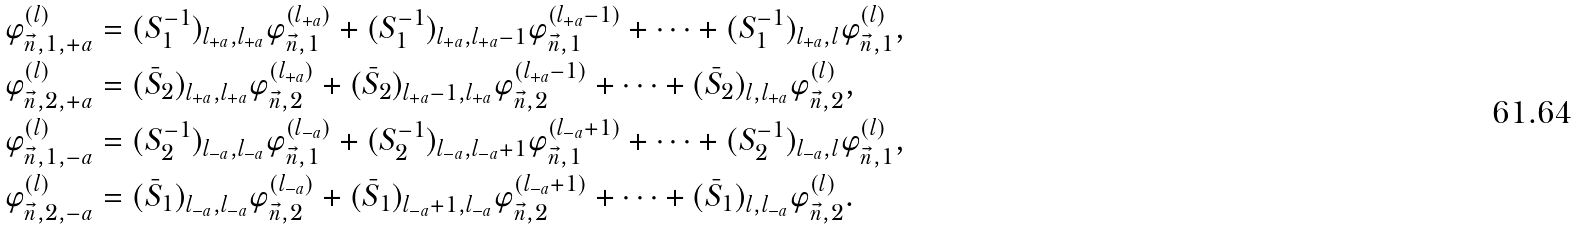<formula> <loc_0><loc_0><loc_500><loc_500>\varphi ^ { ( l ) } _ { \vec { n } , 1 , + a } & = ( S _ { 1 } ^ { - 1 } ) _ { l _ { + a } , l _ { + a } } \varphi ^ { ( l _ { + a } ) } _ { \vec { n } , 1 } + ( S _ { 1 } ^ { - 1 } ) _ { l _ { + a } , l _ { + a } - 1 } \varphi ^ { ( l _ { + a } - 1 ) } _ { \vec { n } , 1 } + \cdots + ( S _ { 1 } ^ { - 1 } ) _ { l _ { + a } , l } \varphi ^ { ( l ) } _ { \vec { n } , 1 } , \\ \varphi ^ { ( l ) } _ { \vec { n } , 2 , + a } & = ( \bar { S } _ { 2 } ) _ { l _ { + a } , l _ { + a } } \varphi ^ { ( l _ { + a } ) } _ { \vec { n } , 2 } + ( \bar { S } _ { 2 } ) _ { l _ { + a } - 1 , l _ { + a } } \varphi ^ { ( l _ { + a } - 1 ) } _ { \vec { n } , 2 } + \cdots + ( \bar { S } _ { 2 } ) _ { l , l _ { + a } } \varphi ^ { ( l ) } _ { \vec { n } , 2 } , \\ \varphi ^ { ( l ) } _ { \vec { n } , 1 , - a } & = ( S _ { 2 } ^ { - 1 } ) _ { l _ { - a } , l _ { - a } } \varphi ^ { ( l _ { - a } ) } _ { \vec { n } , 1 } + ( S _ { 2 } ^ { - 1 } ) _ { l _ { - a } , l _ { - a } + 1 } \varphi ^ { ( l _ { - a } + 1 ) } _ { \vec { n } , 1 } + \dots + ( S _ { 2 } ^ { - 1 } ) _ { l _ { - a } , l } \varphi ^ { ( l ) } _ { \vec { n } , 1 } , \\ \varphi ^ { ( l ) } _ { \vec { n } , 2 , - a } & = ( \bar { S } _ { 1 } ) _ { l _ { - a } , l _ { - a } } \varphi ^ { ( l _ { - a } ) } _ { \vec { n } , 2 } + ( \bar { S } _ { 1 } ) _ { l _ { - a } + 1 , l _ { - a } } \varphi ^ { ( l _ { - a } + 1 ) } _ { \vec { n } , 2 } + \dots + ( \bar { S } _ { 1 } ) _ { l , l _ { - a } } \varphi ^ { ( l ) } _ { \vec { n } , 2 } .</formula> 